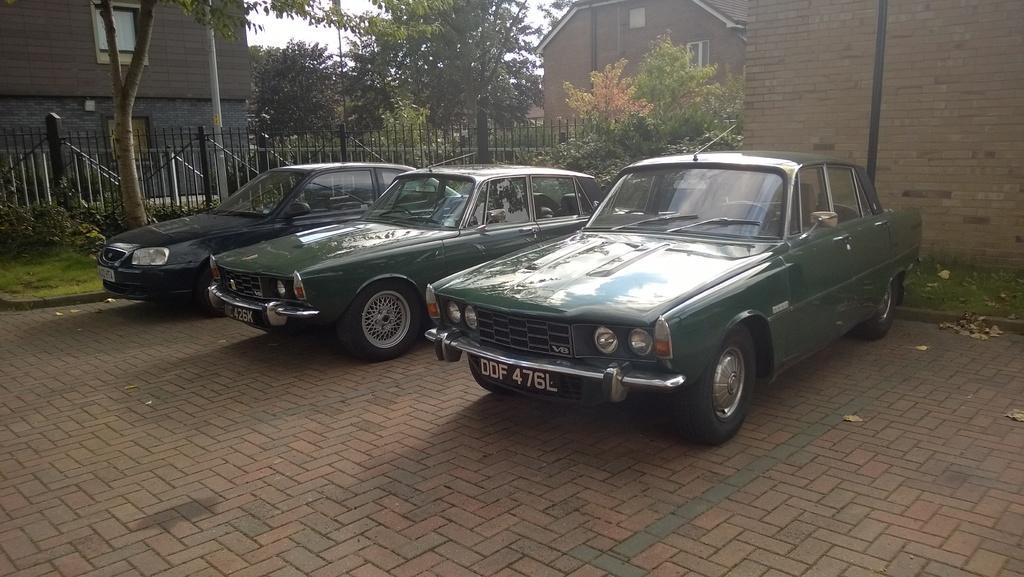Describe this image in one or two sentences. This is an outside view. Here I can see three cars on the ground. On the left side there is a fencing and I can see grass on the ground. In the background there are some trees and buildings and also I can see few poles. At the top of the image I can see the sky. 